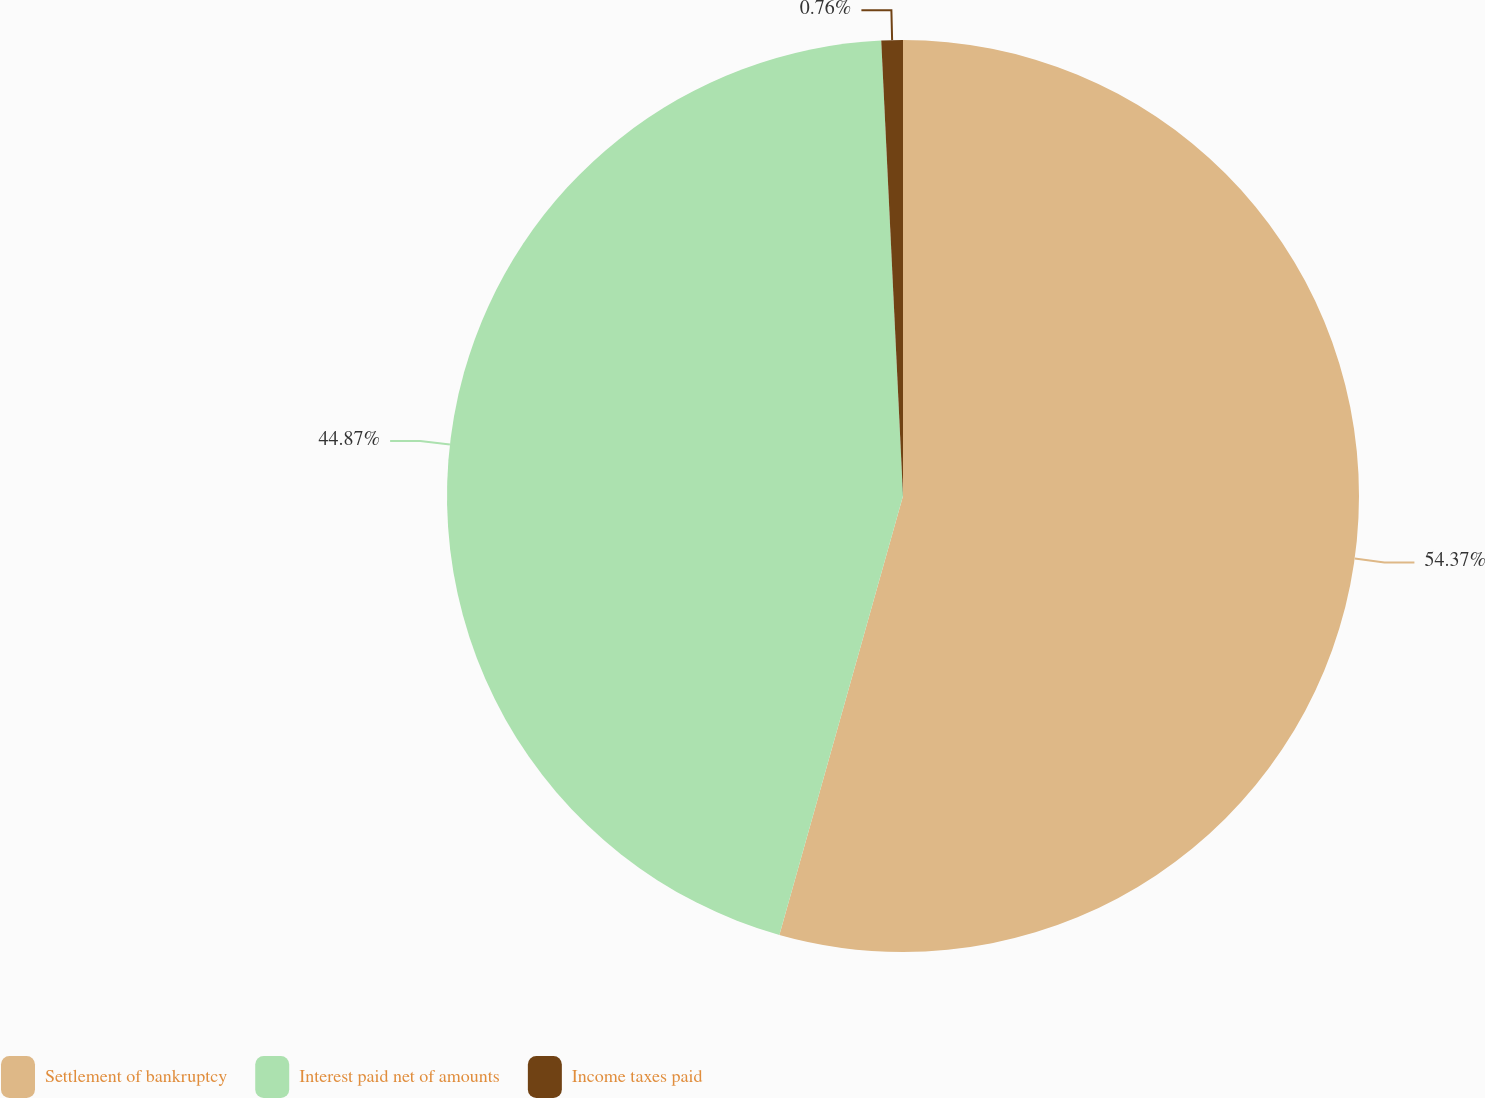<chart> <loc_0><loc_0><loc_500><loc_500><pie_chart><fcel>Settlement of bankruptcy<fcel>Interest paid net of amounts<fcel>Income taxes paid<nl><fcel>54.37%<fcel>44.87%<fcel>0.76%<nl></chart> 